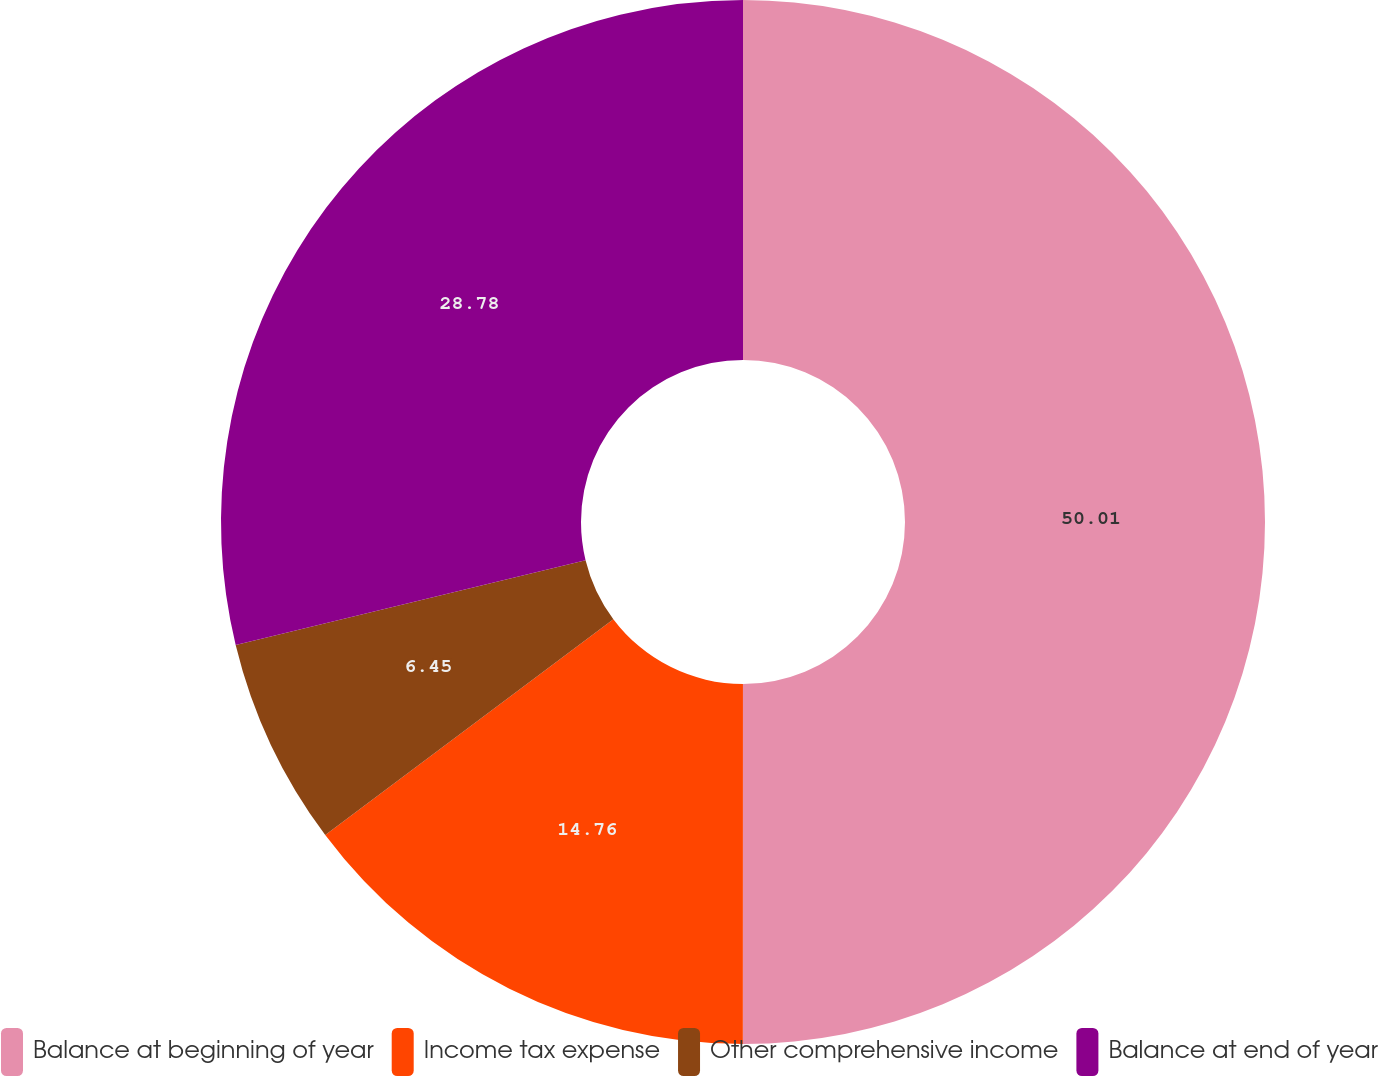<chart> <loc_0><loc_0><loc_500><loc_500><pie_chart><fcel>Balance at beginning of year<fcel>Income tax expense<fcel>Other comprehensive income<fcel>Balance at end of year<nl><fcel>50.0%<fcel>14.76%<fcel>6.45%<fcel>28.78%<nl></chart> 